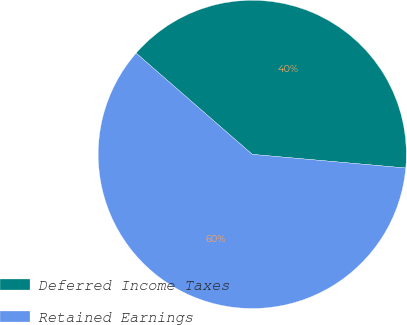Convert chart. <chart><loc_0><loc_0><loc_500><loc_500><pie_chart><fcel>Deferred Income Taxes<fcel>Retained Earnings<nl><fcel>40.0%<fcel>60.0%<nl></chart> 